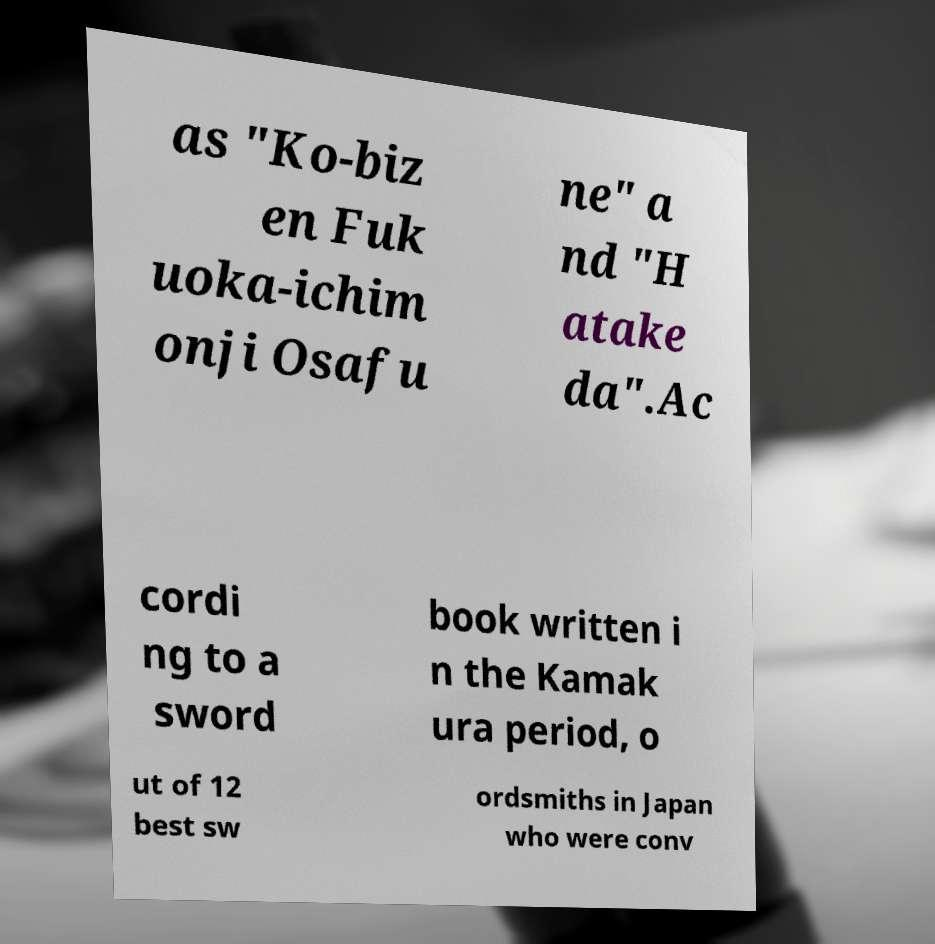What messages or text are displayed in this image? I need them in a readable, typed format. as "Ko-biz en Fuk uoka-ichim onji Osafu ne" a nd "H atake da".Ac cordi ng to a sword book written i n the Kamak ura period, o ut of 12 best sw ordsmiths in Japan who were conv 